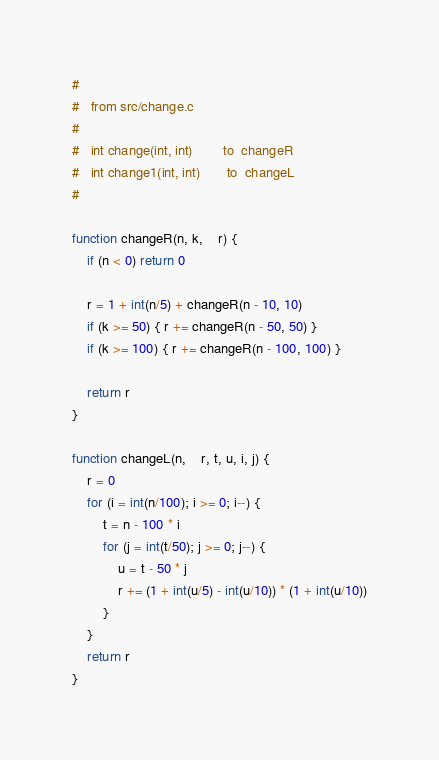Convert code to text. <code><loc_0><loc_0><loc_500><loc_500><_Awk_>#
#	from src/change.c
#
#	int change(int, int)		to	changeR
#	int change1(int, int)		to	changeL
#

function changeR(n, k,	r) {
	if (n < 0) return 0

	r = 1 + int(n/5) + changeR(n - 10, 10)
	if (k >= 50) { r += changeR(n - 50, 50) }
	if (k >= 100) { r += changeR(n - 100, 100) }

	return r
}

function changeL(n,	r, t, u, i, j) {
	r = 0
	for (i = int(n/100); i >= 0; i--) {
		t = n - 100 * i
		for (j = int(t/50); j >= 0; j--) {
			u = t - 50 * j
			r += (1 + int(u/5) - int(u/10)) * (1 + int(u/10))
		}
	}
	return r
}
</code> 